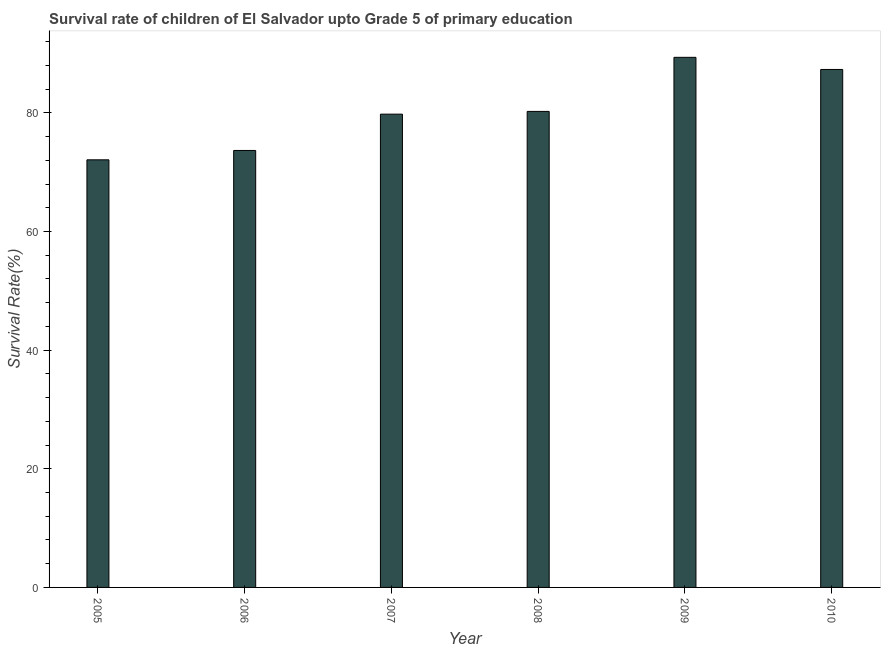Does the graph contain grids?
Ensure brevity in your answer.  No. What is the title of the graph?
Ensure brevity in your answer.  Survival rate of children of El Salvador upto Grade 5 of primary education. What is the label or title of the X-axis?
Provide a short and direct response. Year. What is the label or title of the Y-axis?
Offer a terse response. Survival Rate(%). What is the survival rate in 2010?
Ensure brevity in your answer.  87.32. Across all years, what is the maximum survival rate?
Give a very brief answer. 89.36. Across all years, what is the minimum survival rate?
Offer a very short reply. 72.09. In which year was the survival rate maximum?
Give a very brief answer. 2009. In which year was the survival rate minimum?
Offer a very short reply. 2005. What is the sum of the survival rate?
Make the answer very short. 482.46. What is the difference between the survival rate in 2006 and 2009?
Offer a very short reply. -15.7. What is the average survival rate per year?
Offer a terse response. 80.41. What is the median survival rate?
Keep it short and to the point. 80.02. In how many years, is the survival rate greater than 32 %?
Give a very brief answer. 6. Do a majority of the years between 2007 and 2010 (inclusive) have survival rate greater than 80 %?
Offer a very short reply. Yes. What is the ratio of the survival rate in 2008 to that in 2009?
Your response must be concise. 0.9. Is the survival rate in 2008 less than that in 2010?
Your answer should be compact. Yes. What is the difference between the highest and the second highest survival rate?
Your answer should be compact. 2.05. Is the sum of the survival rate in 2005 and 2010 greater than the maximum survival rate across all years?
Your answer should be very brief. Yes. What is the difference between the highest and the lowest survival rate?
Offer a terse response. 17.28. How many bars are there?
Provide a succinct answer. 6. How many years are there in the graph?
Ensure brevity in your answer.  6. What is the Survival Rate(%) of 2005?
Your answer should be very brief. 72.09. What is the Survival Rate(%) of 2006?
Your answer should be compact. 73.66. What is the Survival Rate(%) in 2007?
Offer a terse response. 79.79. What is the Survival Rate(%) of 2008?
Your answer should be compact. 80.25. What is the Survival Rate(%) of 2009?
Keep it short and to the point. 89.36. What is the Survival Rate(%) in 2010?
Provide a succinct answer. 87.32. What is the difference between the Survival Rate(%) in 2005 and 2006?
Offer a terse response. -1.58. What is the difference between the Survival Rate(%) in 2005 and 2007?
Offer a very short reply. -7.7. What is the difference between the Survival Rate(%) in 2005 and 2008?
Offer a very short reply. -8.16. What is the difference between the Survival Rate(%) in 2005 and 2009?
Offer a terse response. -17.28. What is the difference between the Survival Rate(%) in 2005 and 2010?
Your answer should be compact. -15.23. What is the difference between the Survival Rate(%) in 2006 and 2007?
Give a very brief answer. -6.12. What is the difference between the Survival Rate(%) in 2006 and 2008?
Ensure brevity in your answer.  -6.58. What is the difference between the Survival Rate(%) in 2006 and 2009?
Keep it short and to the point. -15.7. What is the difference between the Survival Rate(%) in 2006 and 2010?
Ensure brevity in your answer.  -13.65. What is the difference between the Survival Rate(%) in 2007 and 2008?
Your answer should be very brief. -0.46. What is the difference between the Survival Rate(%) in 2007 and 2009?
Provide a short and direct response. -9.58. What is the difference between the Survival Rate(%) in 2007 and 2010?
Your answer should be compact. -7.53. What is the difference between the Survival Rate(%) in 2008 and 2009?
Keep it short and to the point. -9.12. What is the difference between the Survival Rate(%) in 2008 and 2010?
Offer a very short reply. -7.07. What is the difference between the Survival Rate(%) in 2009 and 2010?
Your response must be concise. 2.05. What is the ratio of the Survival Rate(%) in 2005 to that in 2006?
Offer a terse response. 0.98. What is the ratio of the Survival Rate(%) in 2005 to that in 2007?
Ensure brevity in your answer.  0.9. What is the ratio of the Survival Rate(%) in 2005 to that in 2008?
Give a very brief answer. 0.9. What is the ratio of the Survival Rate(%) in 2005 to that in 2009?
Provide a short and direct response. 0.81. What is the ratio of the Survival Rate(%) in 2005 to that in 2010?
Make the answer very short. 0.83. What is the ratio of the Survival Rate(%) in 2006 to that in 2007?
Your answer should be compact. 0.92. What is the ratio of the Survival Rate(%) in 2006 to that in 2008?
Provide a short and direct response. 0.92. What is the ratio of the Survival Rate(%) in 2006 to that in 2009?
Offer a very short reply. 0.82. What is the ratio of the Survival Rate(%) in 2006 to that in 2010?
Offer a terse response. 0.84. What is the ratio of the Survival Rate(%) in 2007 to that in 2008?
Make the answer very short. 0.99. What is the ratio of the Survival Rate(%) in 2007 to that in 2009?
Your answer should be compact. 0.89. What is the ratio of the Survival Rate(%) in 2007 to that in 2010?
Ensure brevity in your answer.  0.91. What is the ratio of the Survival Rate(%) in 2008 to that in 2009?
Provide a short and direct response. 0.9. What is the ratio of the Survival Rate(%) in 2008 to that in 2010?
Make the answer very short. 0.92. 